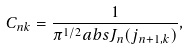<formula> <loc_0><loc_0><loc_500><loc_500>C _ { n k } = \frac { 1 } { \pi ^ { 1 / 2 } a b s { J _ { n } ( j _ { n + 1 , k } ) } } ,</formula> 